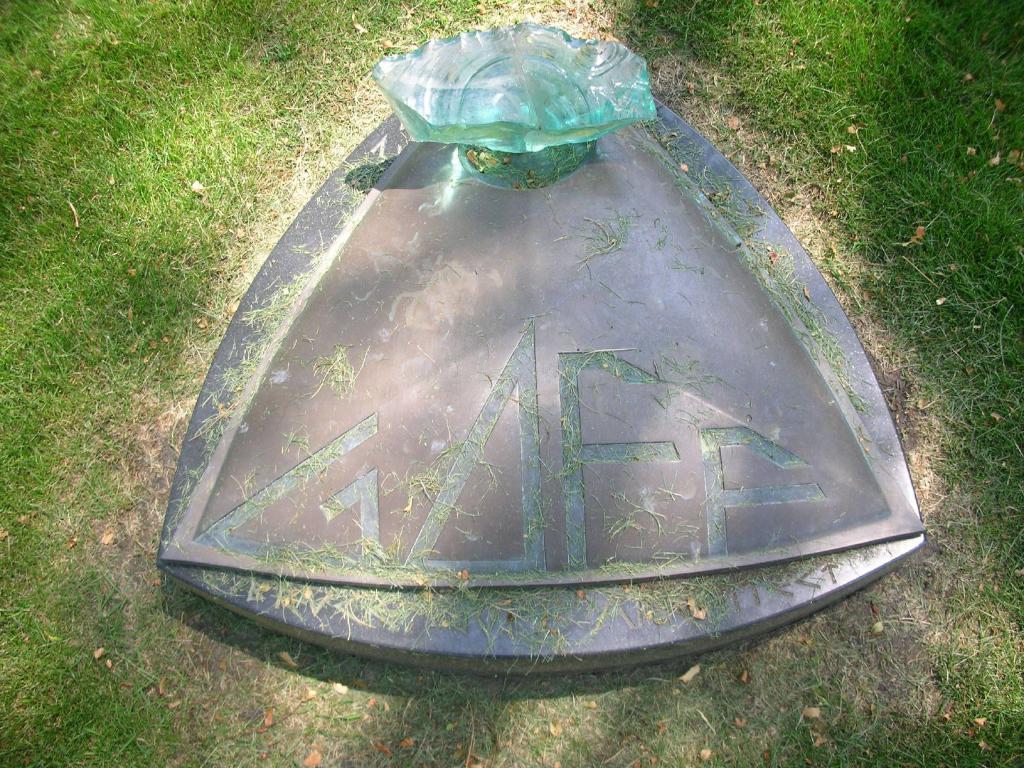Please provide a concise description of this image. In this picture we can see a stone and grass. 